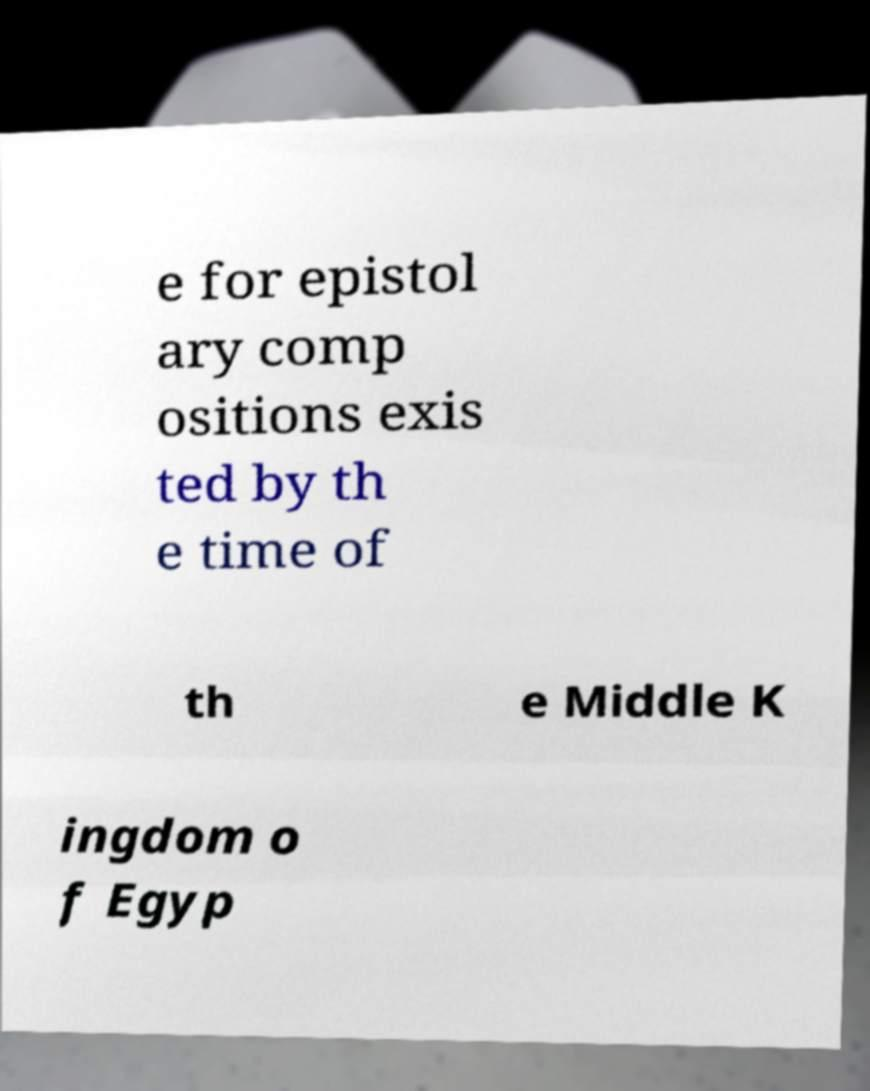Please read and relay the text visible in this image. What does it say? e for epistol ary comp ositions exis ted by th e time of th e Middle K ingdom o f Egyp 